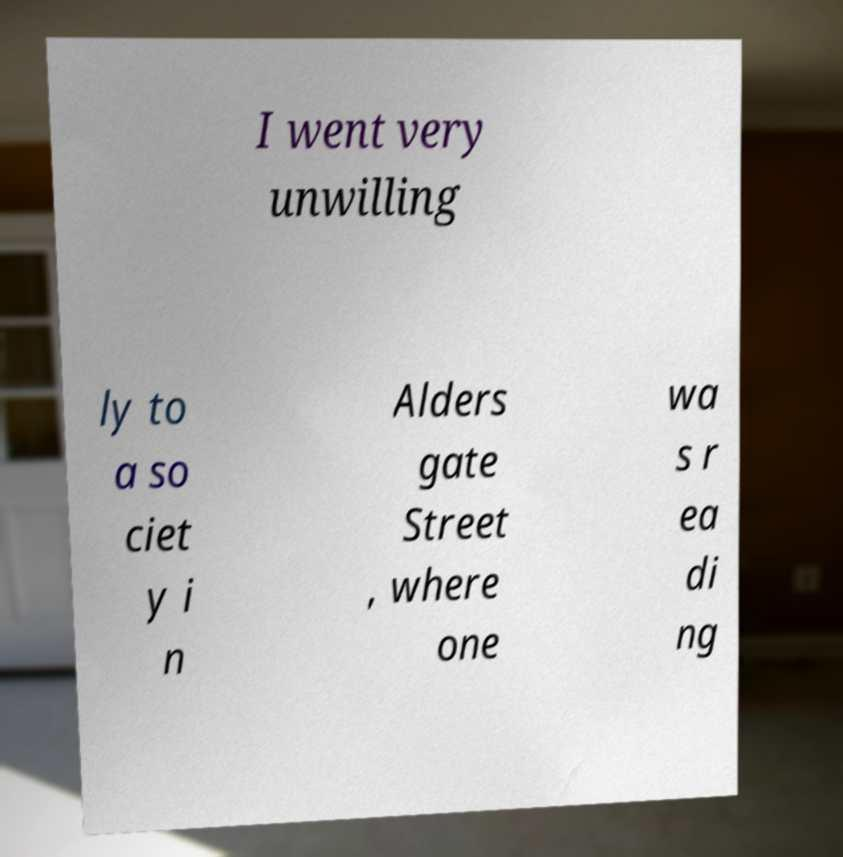For documentation purposes, I need the text within this image transcribed. Could you provide that? I went very unwilling ly to a so ciet y i n Alders gate Street , where one wa s r ea di ng 